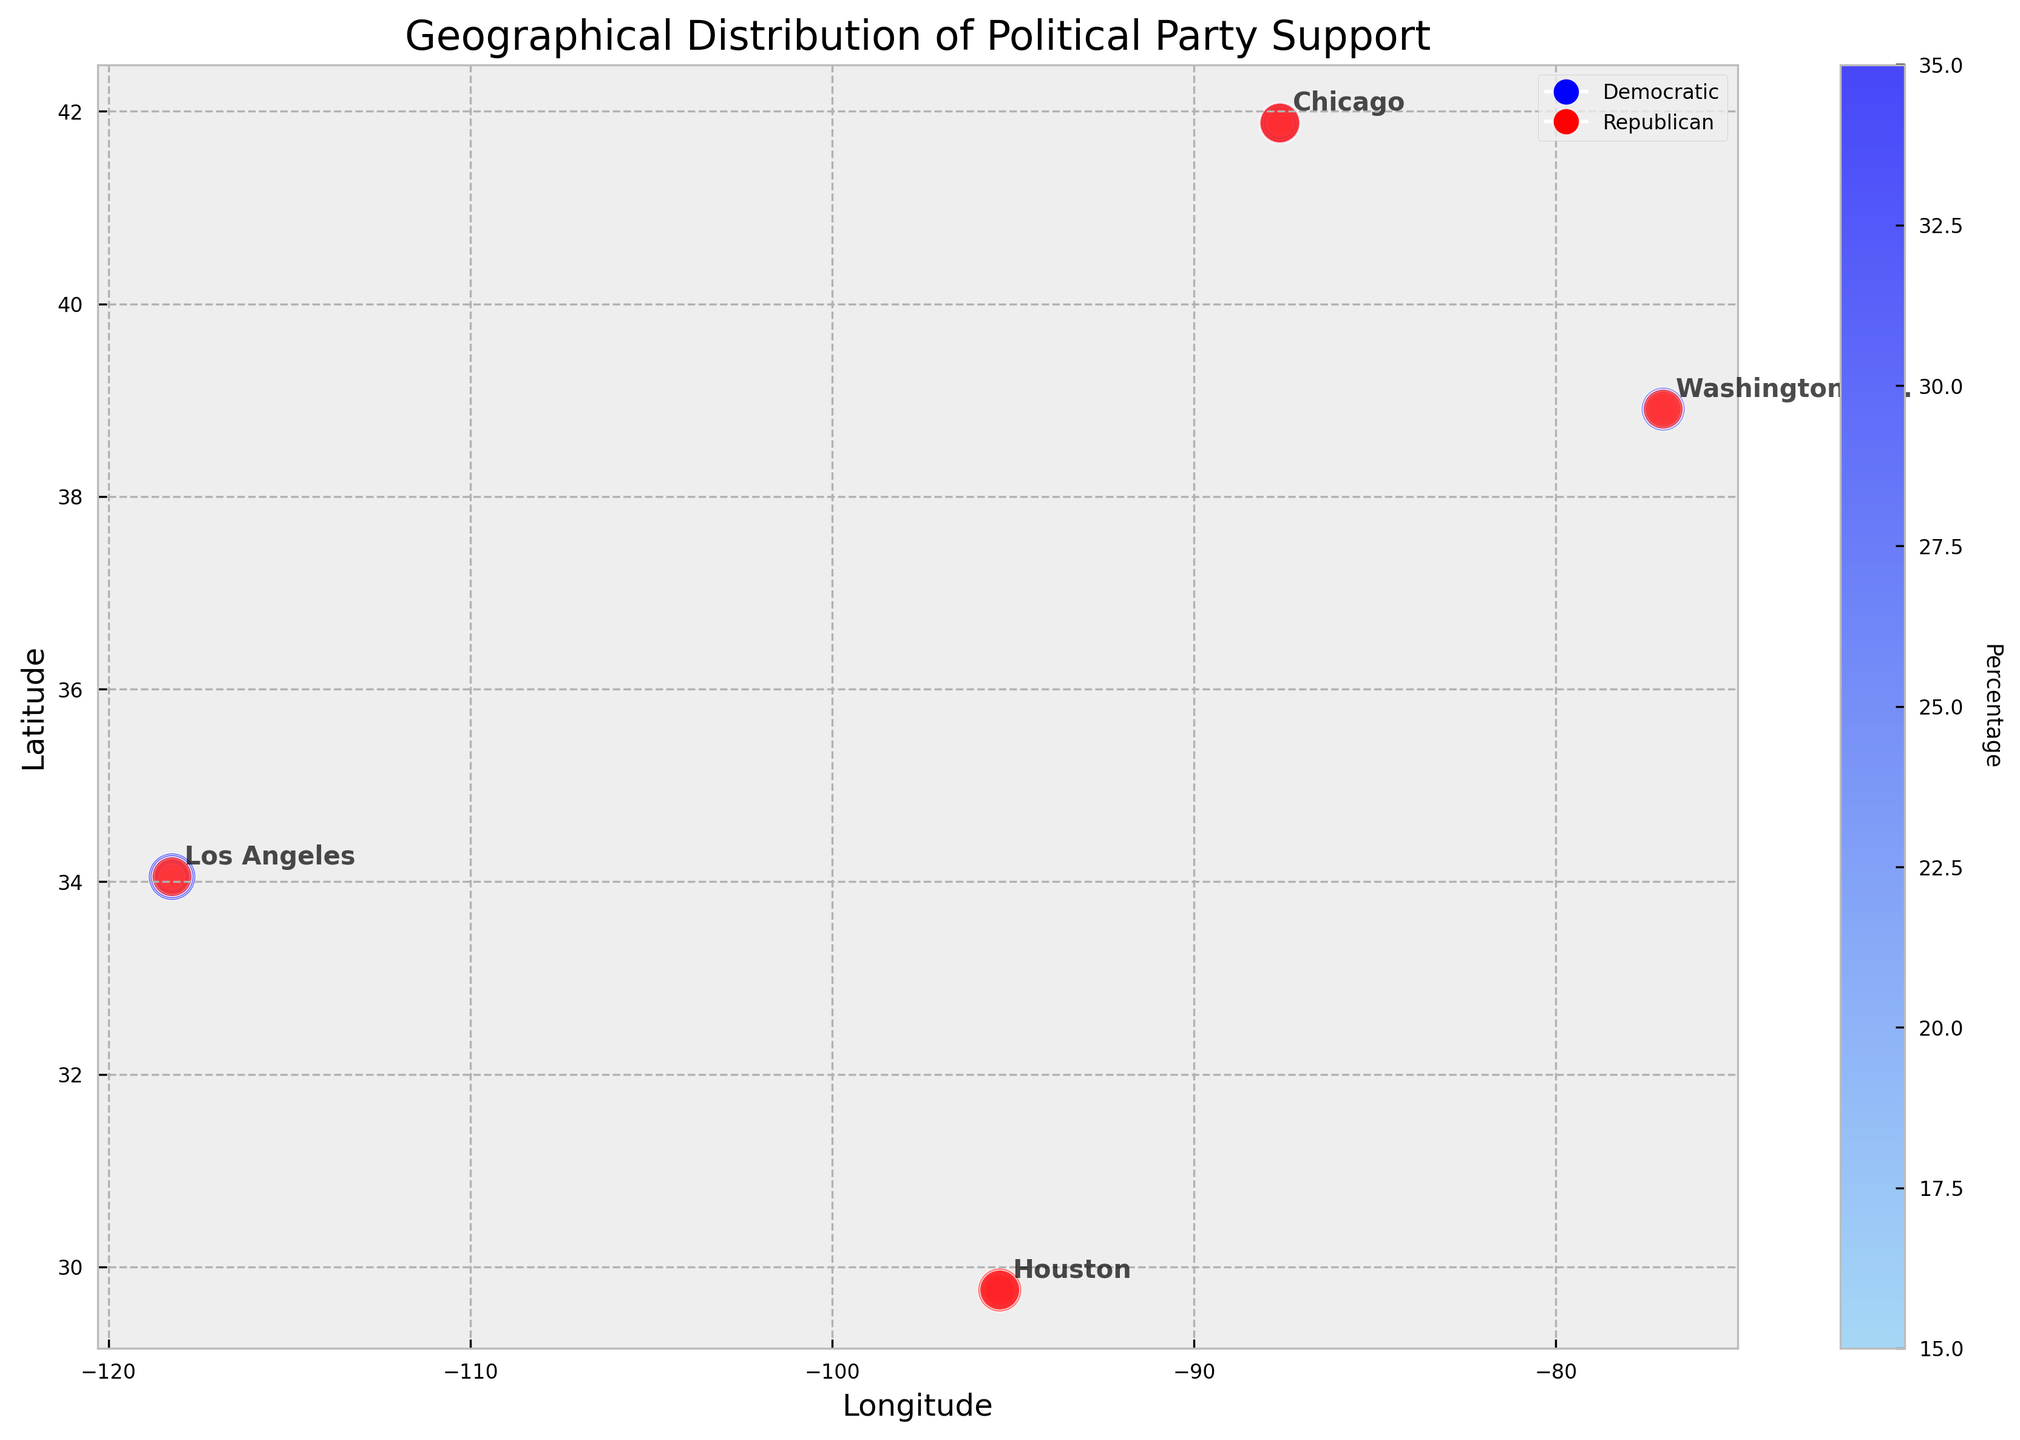What is the title of the figure? The title is displayed at the top center of the figure. It is meant to summarize the information presented in the visual.
Answer: Geographical Distribution of Political Party Support Which party has a higher proportion of supporters aged 18-29 in Los Angeles? Look at the markers on the plot for Los Angeles. The color and size of the markers indicate the percentage. Compare the markers at the specific city location for the Democratic and Republican parties.
Answer: Democratic Why are there different colors on the plot? The different colors represent varying percentages of supporters. The color gradient moves from light to dark, indicating lower to higher percentages respectively for each political party.
Answer: To represent different percentages of supporters Which city has the highest percentage of Republican supporters aged 65+? Identify the city locations on the plot and observe the color and size of markers. The larger and darker red marker will indicate a higher percentage of Republican supporters aged 65+.
Answer: Washington D.C How do the percentages of Democratic supporters aged 45-64 compare between Chicago and Houston? Locate the markers for Democratic supporters aged 45-64 in both Chicago and Houston. Compare the sizes and colors of these markers to assess the percentages. Chicago's percentage appears higher as the marker is larger and darker blue.
Answer: Chicago has a higher percentage Do the percentages of Republican supporters aged 30-44 in Washington D.C. and Houston show a significant difference? Compare the markers for the Republican supporters aged 30-44 in Washington D.C. and Houston. Assess the marker sizes and colors; a more significant difference would be indicated by a noticeable variation in size and color intensity.
Answer: Only a slight difference What can be inferred about the age group distribution of Democratic supporters in Washington D.C.? Look at the sizes and colors of the markers representing each age group for Democratic supporters in Washington D.C. Notice the highest concentration/percentage age group and the general trend.
Answer: Higher support from younger age groups (18-29) Between Los Angeles and Chicago, where do Republican supporters aged 18-29 have a lower percentage? Locate the markers for the Republican supporters aged 18-29 in both cities. Compare the sizes and colors of these markers to assess which city has a lower percentage.
Answer: Los Angeles In which city do Democratic supporters make up a larger percentage of the population overall? This requires summing up the percentages of Democratic supporters across all age groups for each city. The city with the highest cumulative sum will have the largest overall percentage of Democratic supporters.
Answer: Los Angeles 